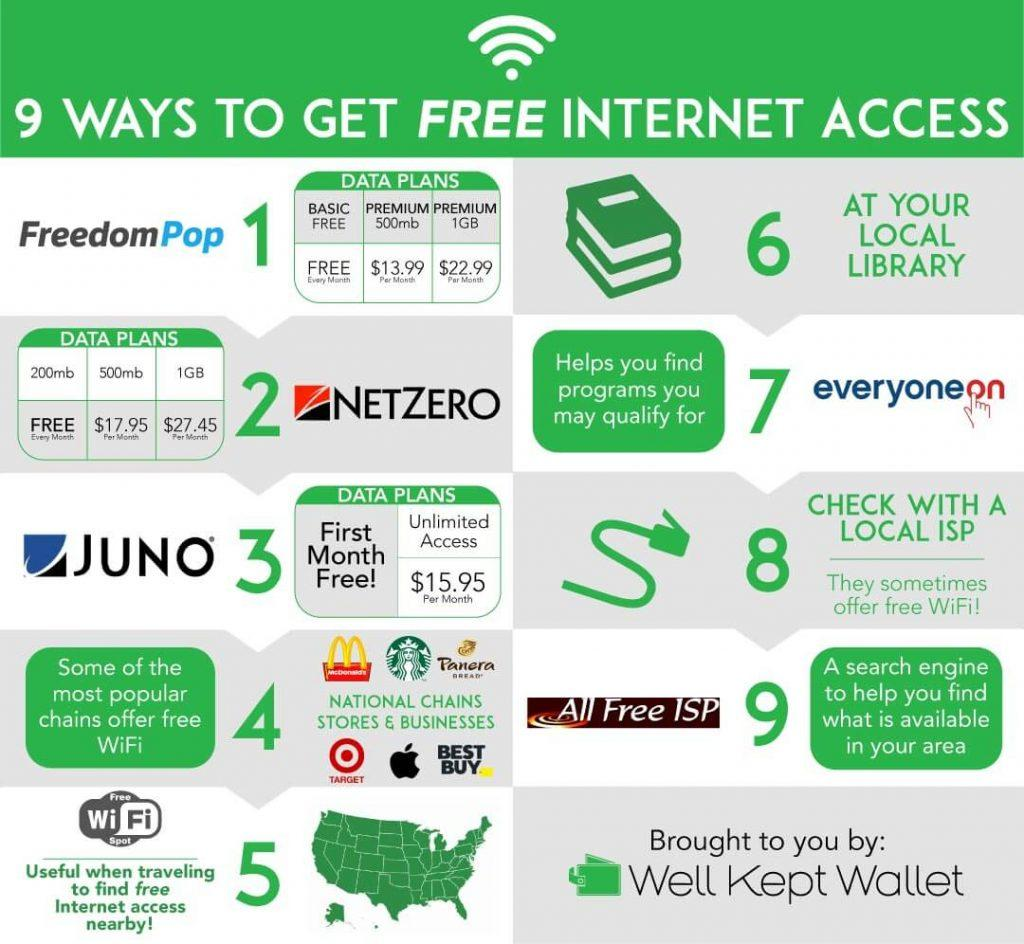Give some essential details in this illustration. Netzero offers a data plan that costs nothing every month, with a 200MB data allowance. The unlimited data plan of JUNO costs $15.95 per month. Netzero's 500mb dataplan costs $17.95 per month. 